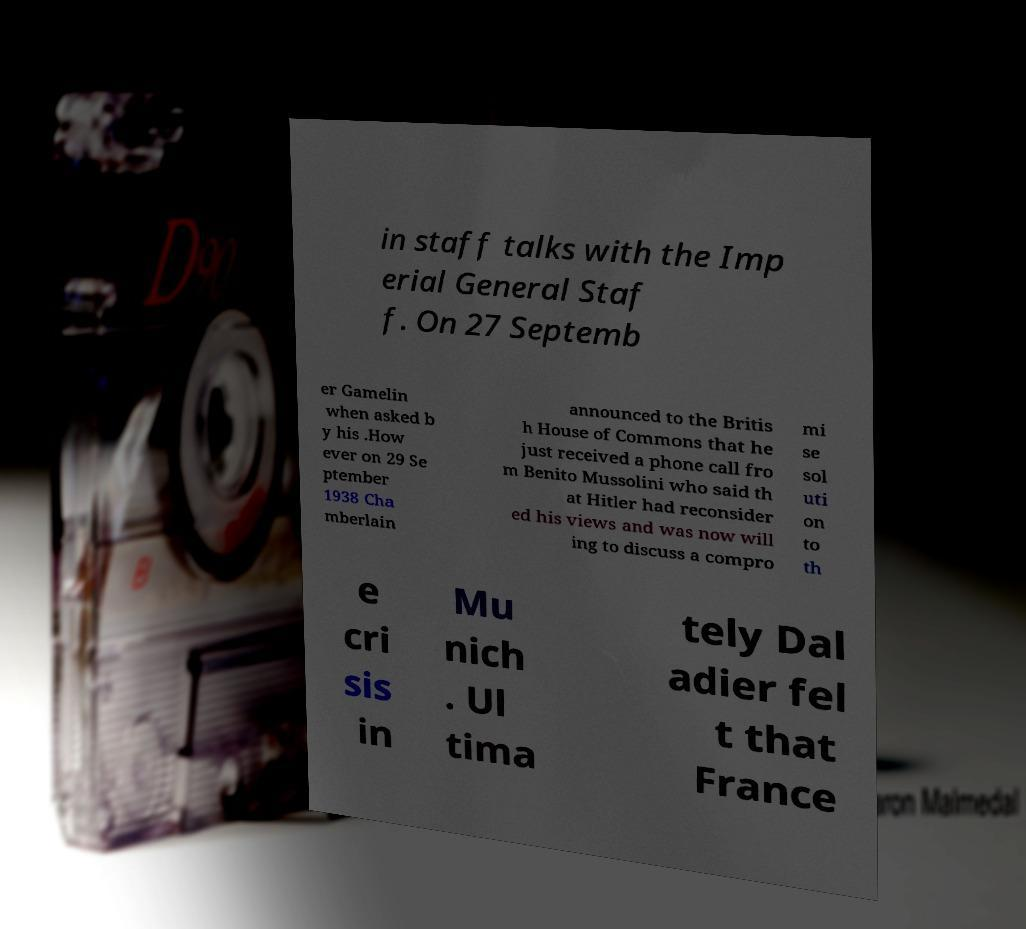Could you assist in decoding the text presented in this image and type it out clearly? in staff talks with the Imp erial General Staf f. On 27 Septemb er Gamelin when asked b y his .How ever on 29 Se ptember 1938 Cha mberlain announced to the Britis h House of Commons that he just received a phone call fro m Benito Mussolini who said th at Hitler had reconsider ed his views and was now will ing to discuss a compro mi se sol uti on to th e cri sis in Mu nich . Ul tima tely Dal adier fel t that France 